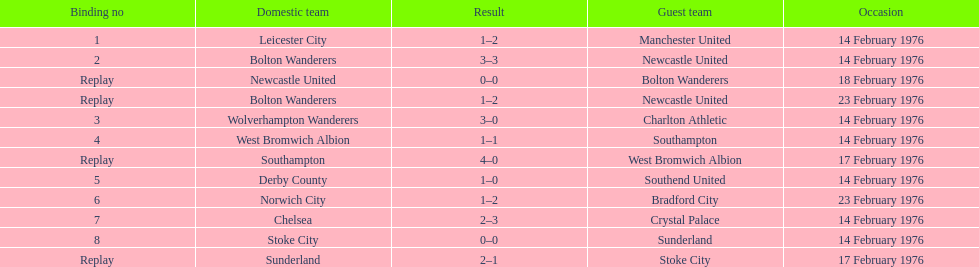What was the number of games that occurred on 14 february 1976? 7. 